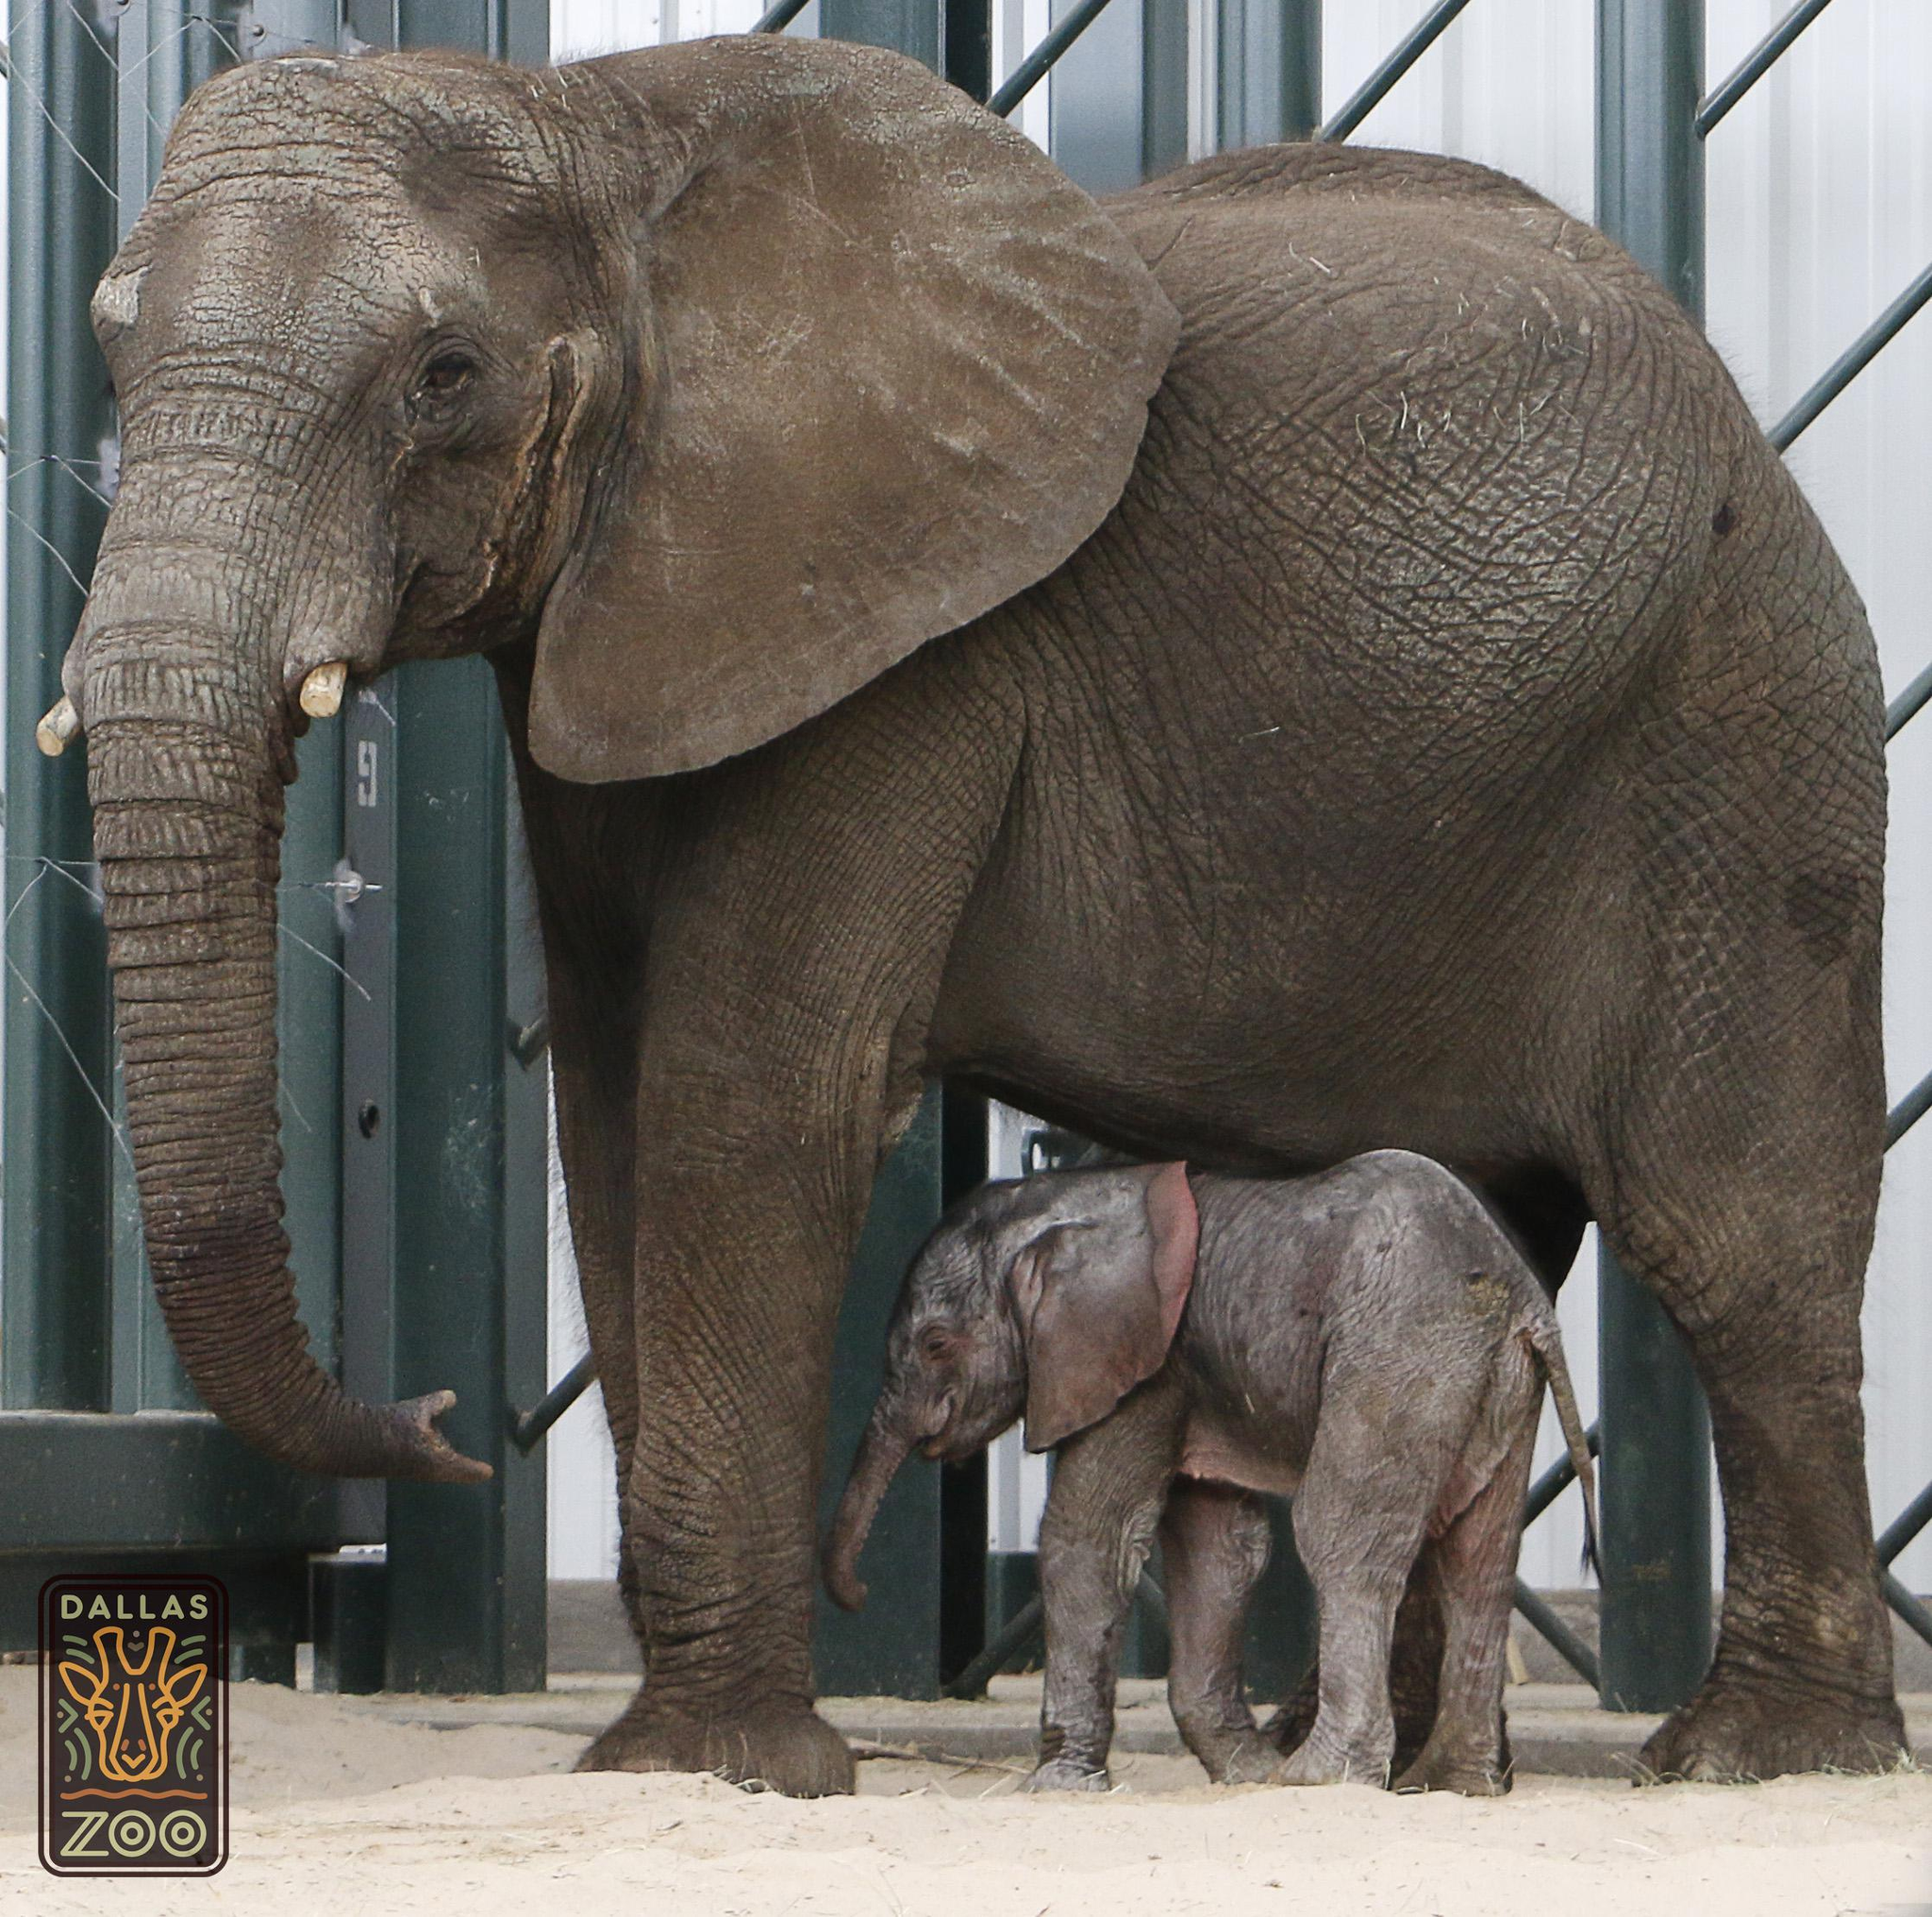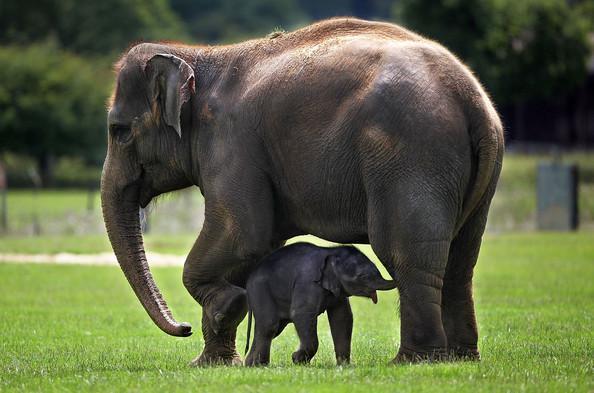The first image is the image on the left, the second image is the image on the right. For the images shown, is this caption "An image shows just one adult elephant interacting with a baby elephant on bright green grass." true? Answer yes or no. Yes. The first image is the image on the left, the second image is the image on the right. For the images shown, is this caption "In each image, at the side of an adult elephant is a baby elephant, approximately tall enough to reach the underside of the adult's belly area." true? Answer yes or no. Yes. 